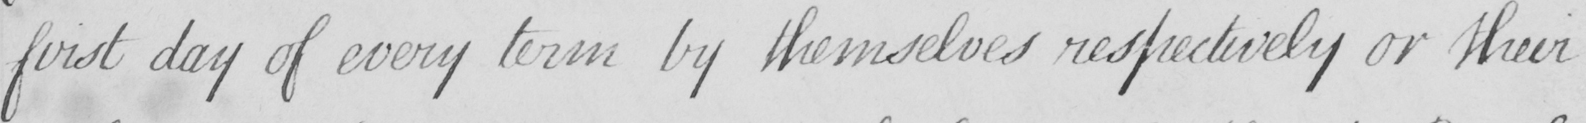Can you tell me what this handwritten text says? first day of every term by themselves respectively or their 